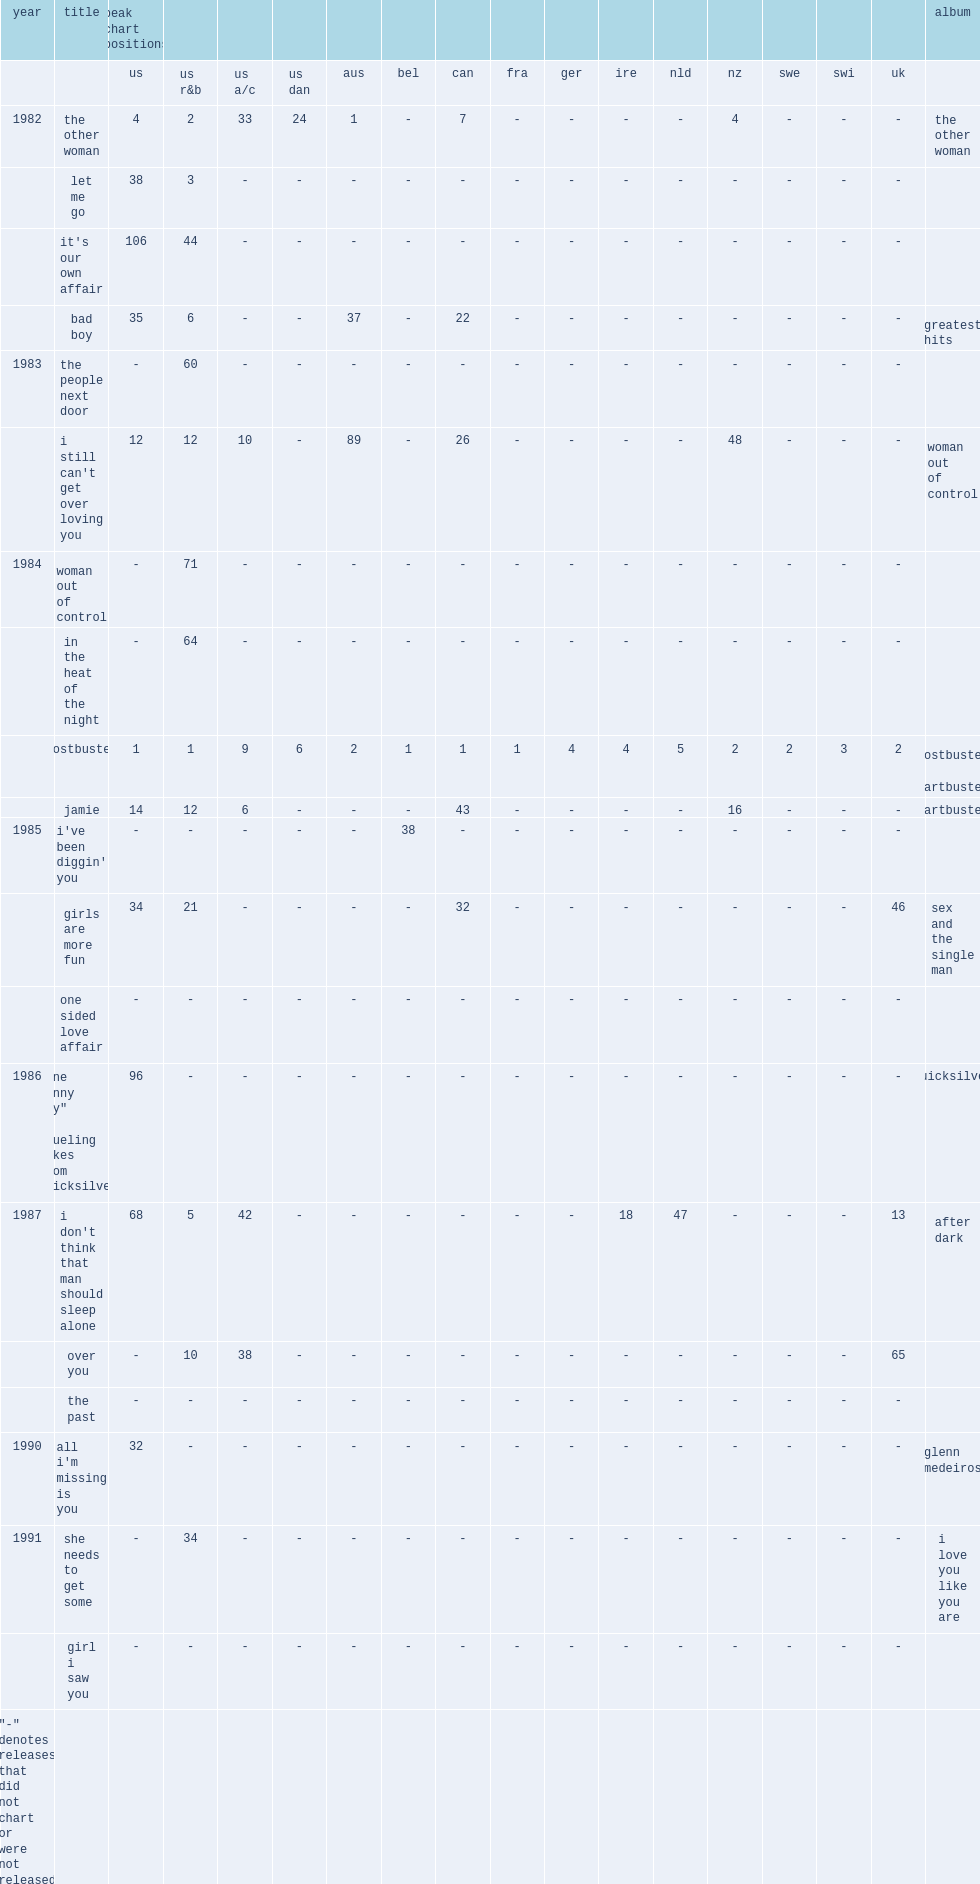When did the single "the other woman" (#4) release? 1982.0. Would you be able to parse every entry in this table? {'header': ['year', 'title', 'peak chart positions', '', '', '', '', '', '', '', '', '', '', '', '', '', '', 'album'], 'rows': [['', '', 'us', 'us r&b', 'us a/c', 'us dan', 'aus', 'bel', 'can', 'fra', 'ger', 'ire', 'nld', 'nz', 'swe', 'swi', 'uk', ''], ['1982', 'the other woman', '4', '2', '33', '24', '1', '-', '7', '-', '-', '-', '-', '4', '-', '-', '-', 'the other woman'], ['', 'let me go', '38', '3', '-', '-', '-', '-', '-', '-', '-', '-', '-', '-', '-', '-', '-', ''], ['', "it's our own affair", '106', '44', '-', '-', '-', '-', '-', '-', '-', '-', '-', '-', '-', '-', '-', ''], ['', 'bad boy', '35', '6', '-', '-', '37', '-', '22', '-', '-', '-', '-', '-', '-', '-', '-', 'greatest hits'], ['1983', 'the people next door', '-', '60', '-', '-', '-', '-', '-', '-', '-', '-', '-', '-', '-', '-', '-', ''], ['', "i still can't get over loving you", '12', '12', '10', '-', '89', '-', '26', '-', '-', '-', '-', '48', '-', '-', '-', 'woman out of control'], ['1984', 'woman out of control', '-', '71', '-', '-', '-', '-', '-', '-', '-', '-', '-', '-', '-', '-', '-', ''], ['', 'in the heat of the night', '-', '64', '-', '-', '-', '-', '-', '-', '-', '-', '-', '-', '-', '-', '-', ''], ['', 'ghostbusters', '1', '1', '9', '6', '2', '1', '1', '1', '4', '4', '5', '2', '2', '3', '2', 'ghostbusters / chartbusters'], ['', 'jamie', '14', '12', '6', '-', '-', '-', '43', '-', '-', '-', '-', '16', '-', '-', '-', 'chartbusters'], ['1985', "i've been diggin' you", '-', '-', '-', '-', '-', '38', '-', '-', '-', '-', '-', '-', '-', '-', '-', ''], ['', 'girls are more fun', '34', '21', '-', '-', '-', '-', '32', '-', '-', '-', '-', '-', '-', '-', '46', 'sex and the single man'], ['', 'one sided love affair', '-', '-', '-', '-', '-', '-', '-', '-', '-', '-', '-', '-', '-', '-', '-', ''], ['1986', '"one sunny day" / "dueling bikes from quicksilver"', '96', '-', '-', '-', '-', '-', '-', '-', '-', '-', '-', '-', '-', '-', '-', 'quicksilver'], ['1987', "i don't think that man should sleep alone", '68', '5', '42', '-', '-', '-', '-', '-', '-', '18', '47', '-', '-', '-', '13', 'after dark'], ['', 'over you', '-', '10', '38', '-', '-', '-', '-', '-', '-', '-', '-', '-', '-', '-', '65', ''], ['', 'the past', '-', '-', '-', '-', '-', '-', '-', '-', '-', '-', '-', '-', '-', '-', '-', ''], ['1990', "all i'm missing is you", '32', '-', '-', '-', '-', '-', '-', '-', '-', '-', '-', '-', '-', '-', '-', 'glenn medeiros'], ['1991', 'she needs to get some', '-', '34', '-', '-', '-', '-', '-', '-', '-', '-', '-', '-', '-', '-', '-', 'i love you like you are'], ['', 'girl i saw you', '-', '-', '-', '-', '-', '-', '-', '-', '-', '-', '-', '-', '-', '-', '-', ''], ['"-" denotes releases that did not chart or were not released', '', '', '', '', '', '', '', '', '', '', '', '', '', '', '', '', '']]} 